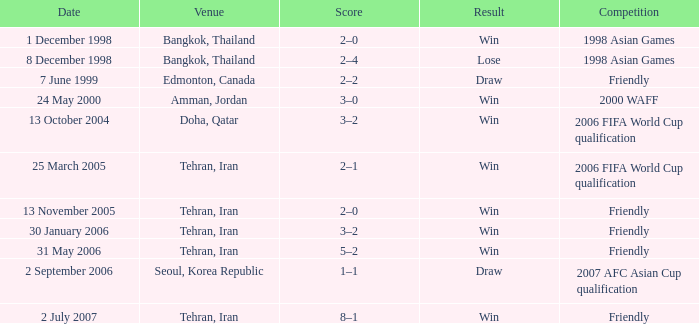I'm looking to parse the entire table for insights. Could you assist me with that? {'header': ['Date', 'Venue', 'Score', 'Result', 'Competition'], 'rows': [['1 December 1998', 'Bangkok, Thailand', '2–0', 'Win', '1998 Asian Games'], ['8 December 1998', 'Bangkok, Thailand', '2–4', 'Lose', '1998 Asian Games'], ['7 June 1999', 'Edmonton, Canada', '2–2', 'Draw', 'Friendly'], ['24 May 2000', 'Amman, Jordan', '3–0', 'Win', '2000 WAFF'], ['13 October 2004', 'Doha, Qatar', '3–2', 'Win', '2006 FIFA World Cup qualification'], ['25 March 2005', 'Tehran, Iran', '2–1', 'Win', '2006 FIFA World Cup qualification'], ['13 November 2005', 'Tehran, Iran', '2–0', 'Win', 'Friendly'], ['30 January 2006', 'Tehran, Iran', '3–2', 'Win', 'Friendly'], ['31 May 2006', 'Tehran, Iran', '5–2', 'Win', 'Friendly'], ['2 September 2006', 'Seoul, Korea Republic', '1–1', 'Draw', '2007 AFC Asian Cup qualification'], ['2 July 2007', 'Tehran, Iran', '8–1', 'Win', 'Friendly']]} What was the competition on 13 November 2005? Friendly. 